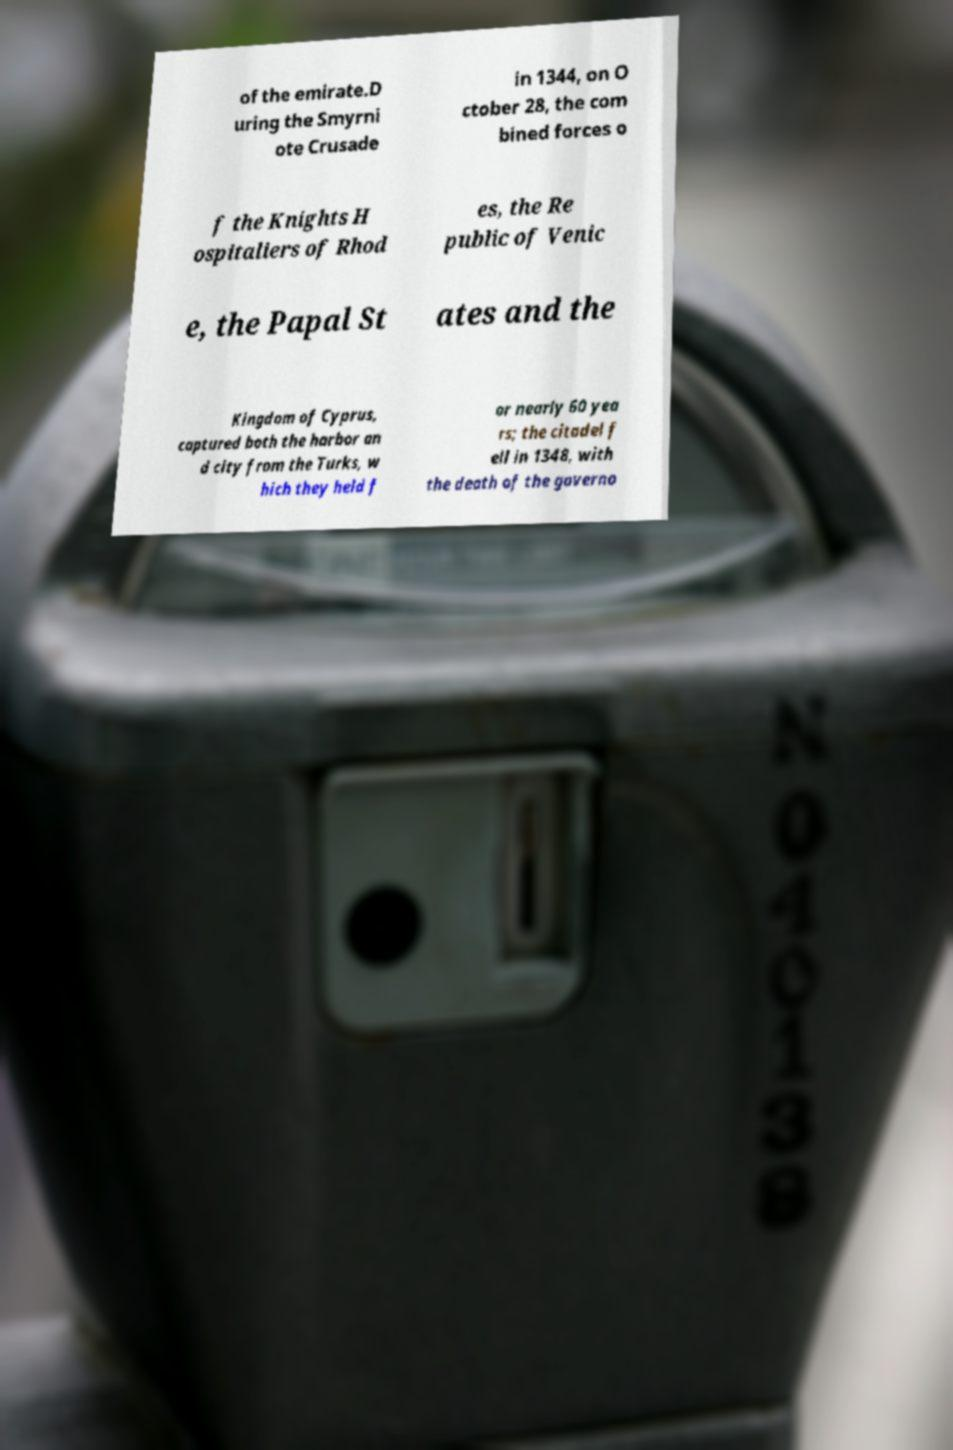Please identify and transcribe the text found in this image. of the emirate.D uring the Smyrni ote Crusade in 1344, on O ctober 28, the com bined forces o f the Knights H ospitaliers of Rhod es, the Re public of Venic e, the Papal St ates and the Kingdom of Cyprus, captured both the harbor an d city from the Turks, w hich they held f or nearly 60 yea rs; the citadel f ell in 1348, with the death of the governo 